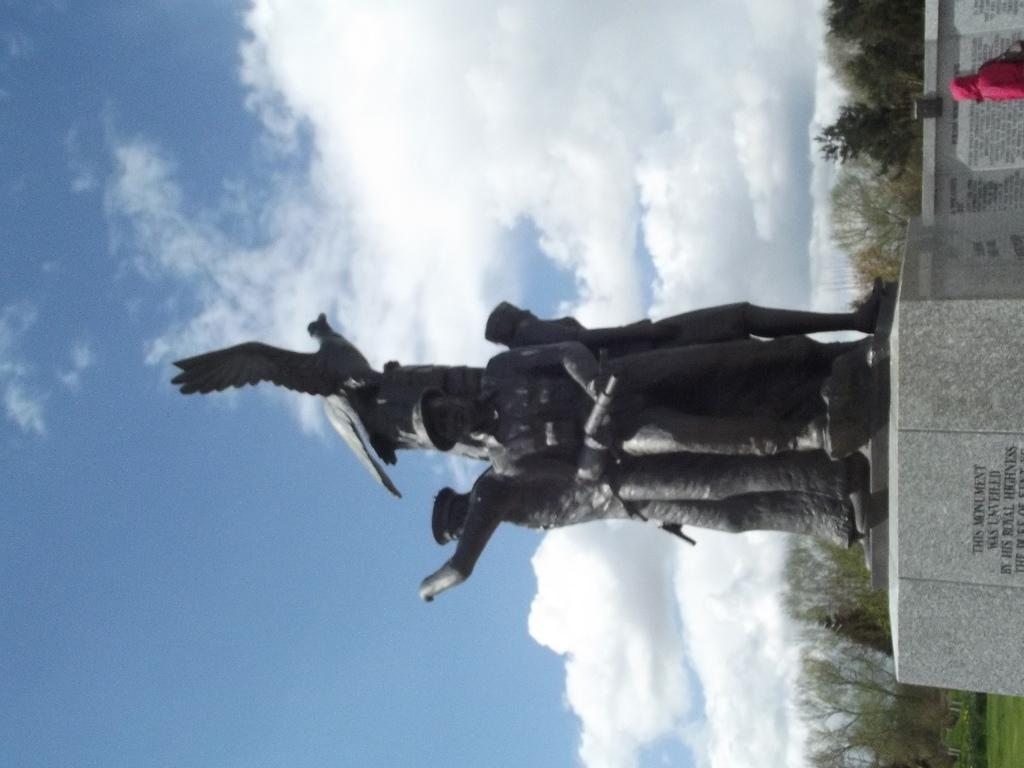What type of objects can be seen in the image? There are statues in the image. What other natural elements are present in the image? There are trees in the image. What is visible in the background of the image? The sky is visible in the image. What can be observed in the sky? Clouds are present in the sky. What type of cloud selection is available in the image? There is no mention of a cloud selection in the image; clouds are simply present in the sky. 